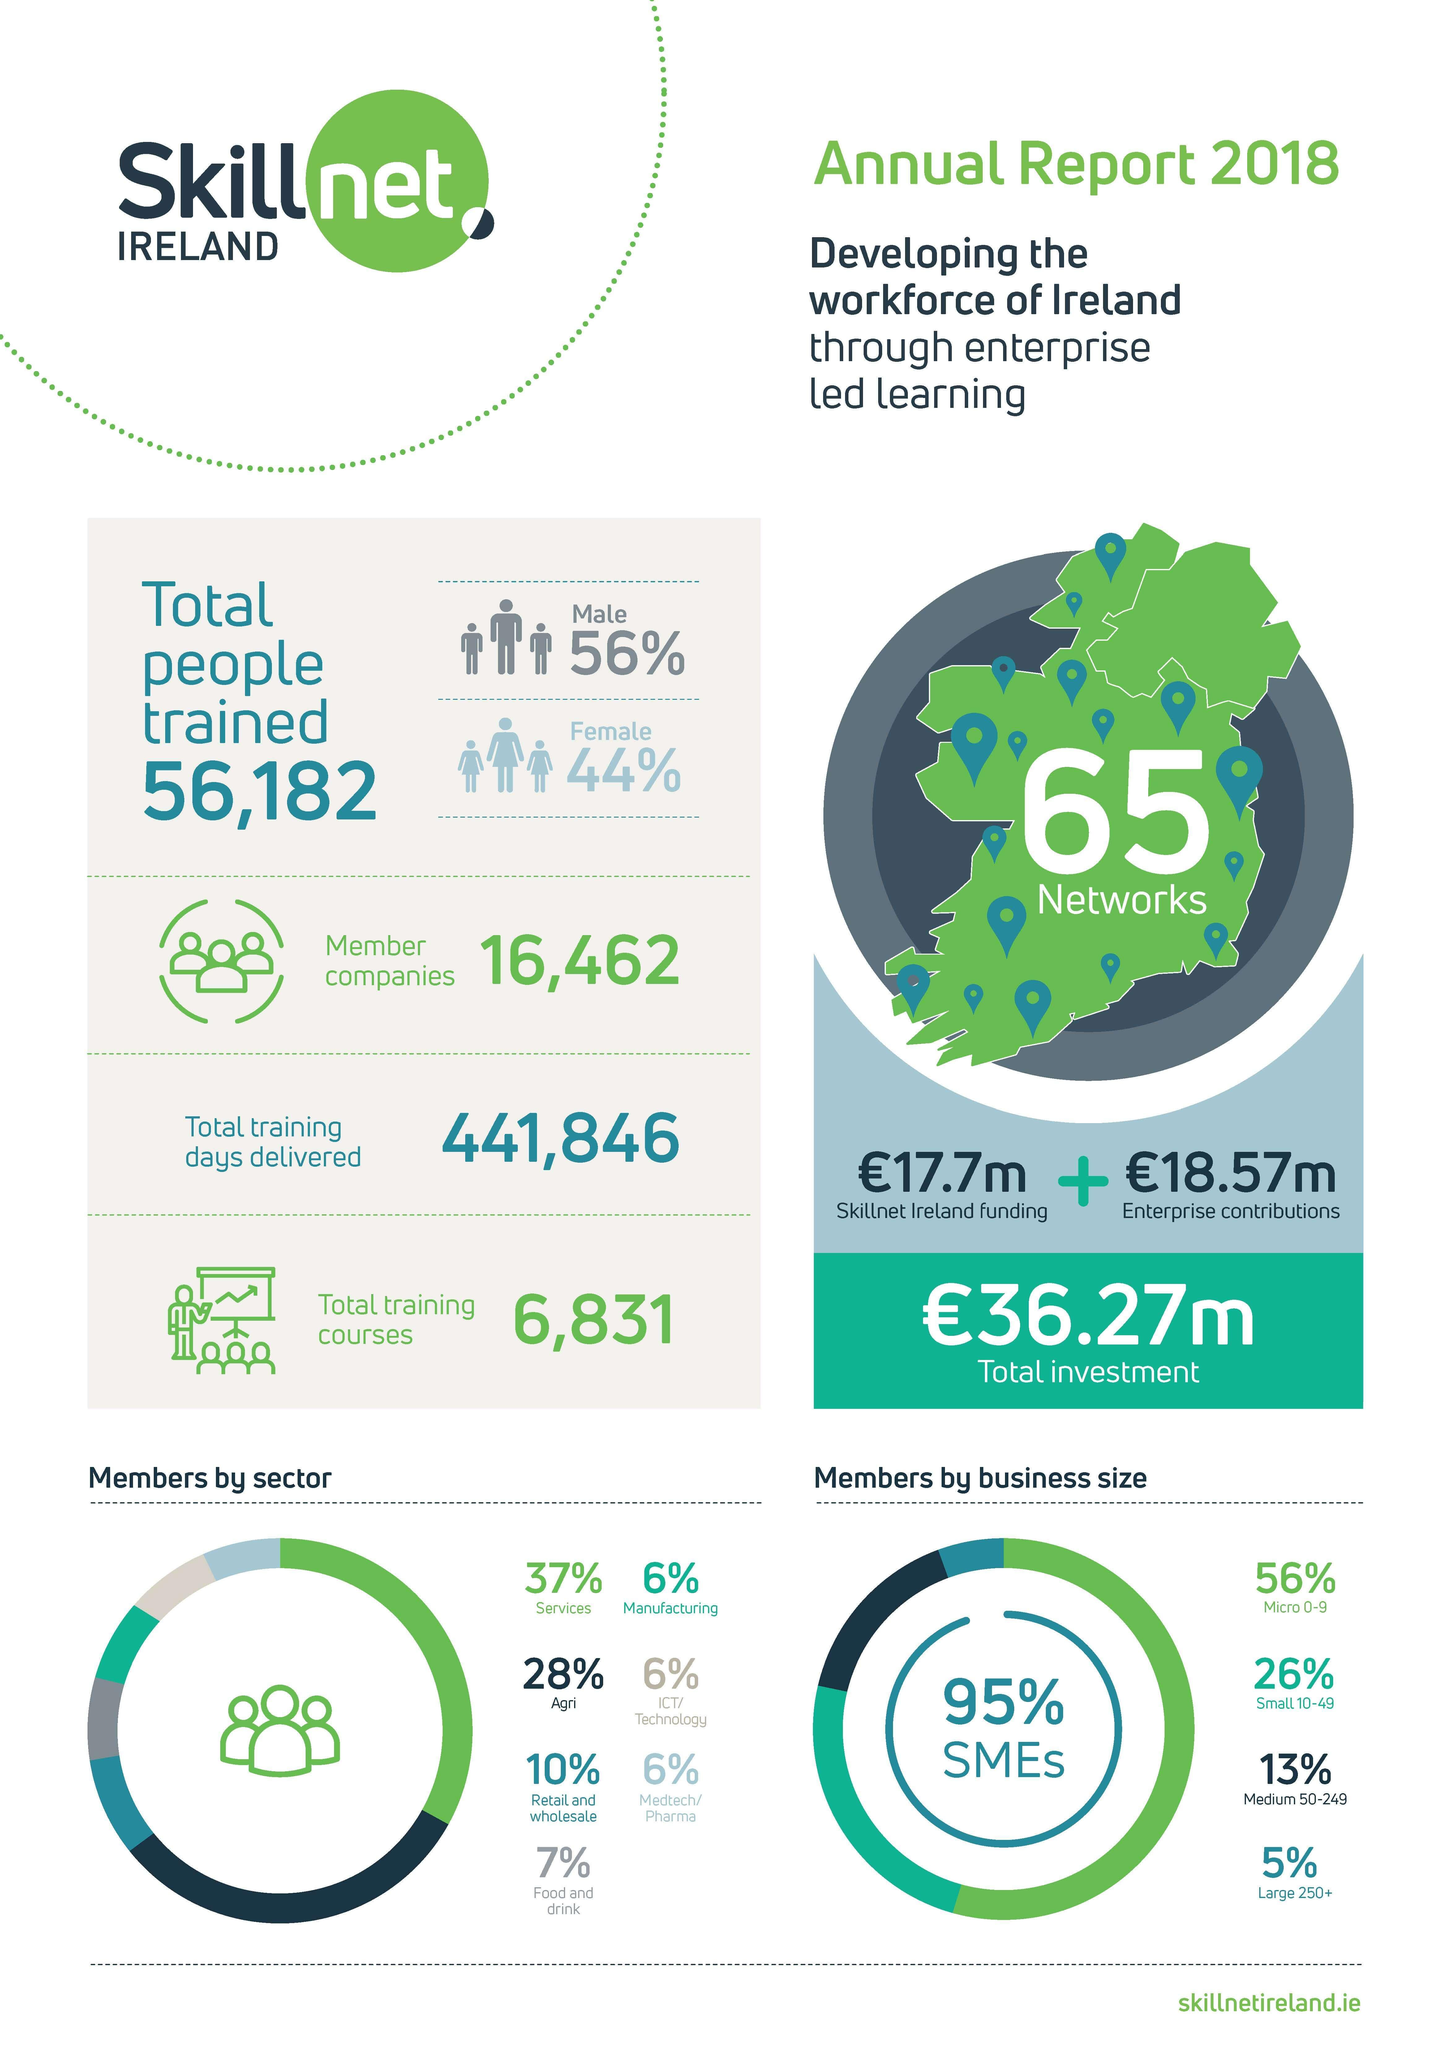Specify some key components in this picture. The total percentage of members who are not from the services, agriculture, or retail and wholesale sectors is 25%. The total percentage of members from the services and agriculture sectors is 65%. According to our survey, 86% of our members are engaged in small or micro scale businesses. According to our data, 39% of our members are engaged in small or medium scale businesses. According to the data, the sectors of manufacturing, ICT/technology, and medtech/pharma all have a similar percentage of members. 